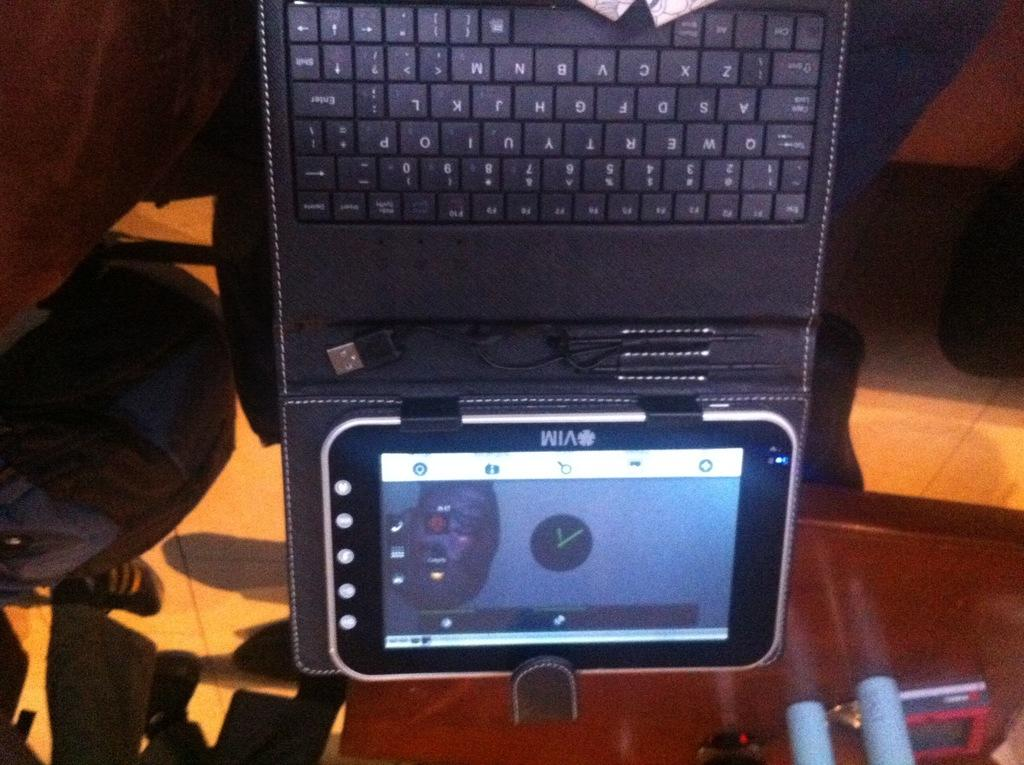Provide a one-sentence caption for the provided image. A VIM tablet is attached to a black keyboard and shows the time in the middle of the screen. 